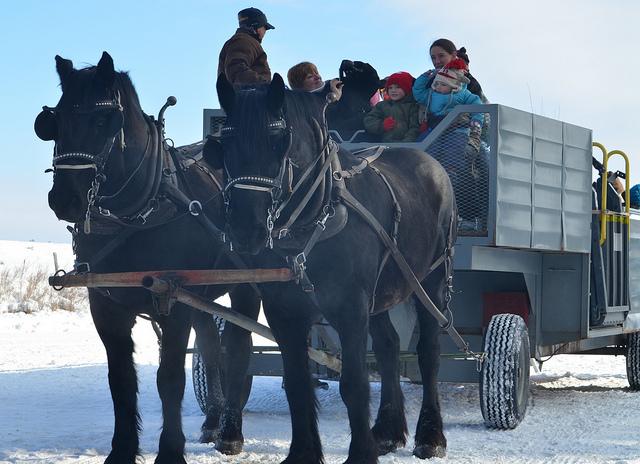Are they sitting on horses?
Short answer required. No. Are the horses wearing blinders?
Be succinct. Yes. How many horses are going to pull this cart?
Answer briefly. 2. Why are the people wearing warm clothing?
Answer briefly. Cold. 